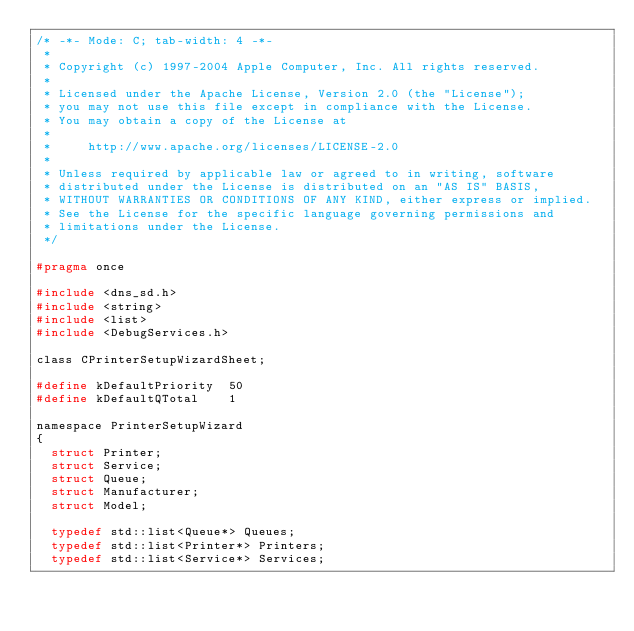<code> <loc_0><loc_0><loc_500><loc_500><_C_>/* -*- Mode: C; tab-width: 4 -*-
 *
 * Copyright (c) 1997-2004 Apple Computer, Inc. All rights reserved.
 *
 * Licensed under the Apache License, Version 2.0 (the "License");
 * you may not use this file except in compliance with the License.
 * You may obtain a copy of the License at
 * 
 *     http://www.apache.org/licenses/LICENSE-2.0
 * 
 * Unless required by applicable law or agreed to in writing, software
 * distributed under the License is distributed on an "AS IS" BASIS,
 * WITHOUT WARRANTIES OR CONDITIONS OF ANY KIND, either express or implied.
 * See the License for the specific language governing permissions and
 * limitations under the License.
 */

#pragma once

#include <dns_sd.h>
#include <string>
#include <list>
#include <DebugServices.h>

class CPrinterSetupWizardSheet;

#define	kDefaultPriority	50
#define kDefaultQTotal		1

namespace PrinterSetupWizard
{
	struct Printer;
	struct Service;
	struct Queue;
	struct Manufacturer;
	struct Model;

	typedef std::list<Queue*>	Queues;
	typedef std::list<Printer*>	Printers;
	typedef std::list<Service*>	Services;</code> 